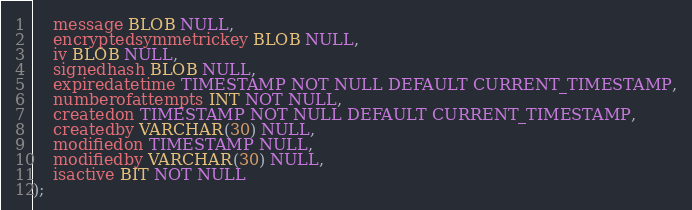Convert code to text. <code><loc_0><loc_0><loc_500><loc_500><_SQL_>    message BLOB NULL,
    encryptedsymmetrickey BLOB NULL,
    iv BLOB NULL,
    signedhash BLOB NULL,
    expiredatetime TIMESTAMP NOT NULL DEFAULT CURRENT_TIMESTAMP,
    numberofattempts INT NOT NULL,
    createdon TIMESTAMP NOT NULL DEFAULT CURRENT_TIMESTAMP,
    createdby VARCHAR(30) NULL,
    modifiedon TIMESTAMP NULL,
    modifiedby VARCHAR(30) NULL,
    isactive BIT NOT NULL
);</code> 